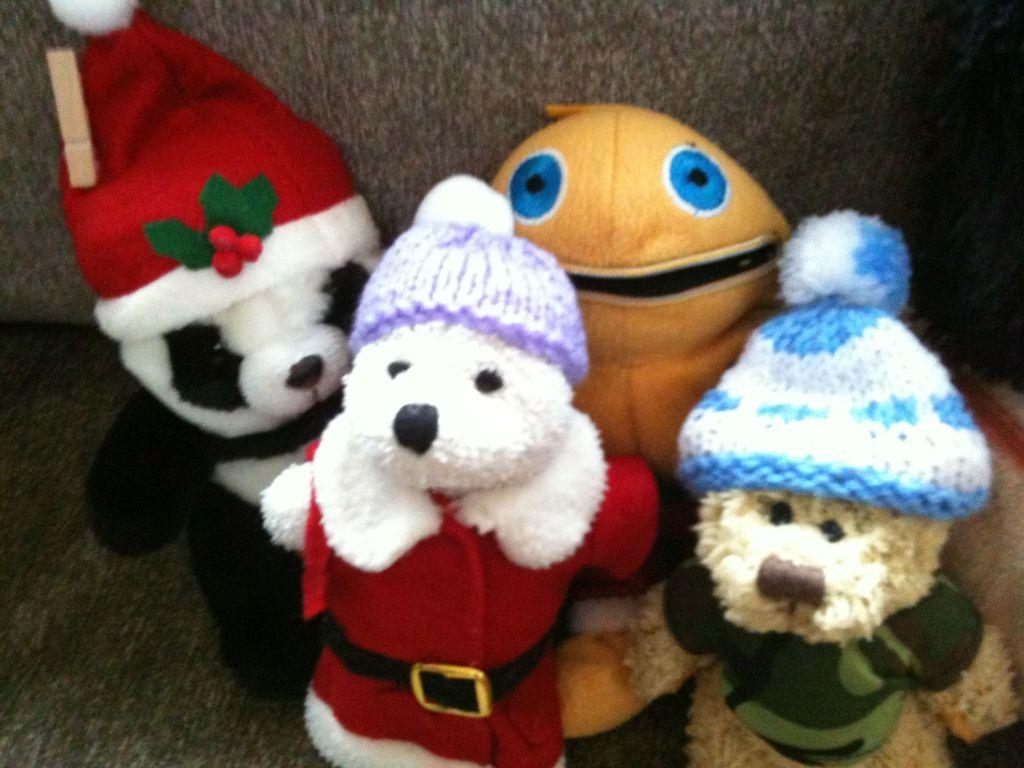What objects can be seen in the image? There are toys in the image. Where are the toys located? The toys are on a couch. How many cats are sitting on the hydrant in the image? There are no cats or hydrants present in the image; it only features toys on a couch. 